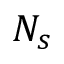<formula> <loc_0><loc_0><loc_500><loc_500>N _ { s }</formula> 